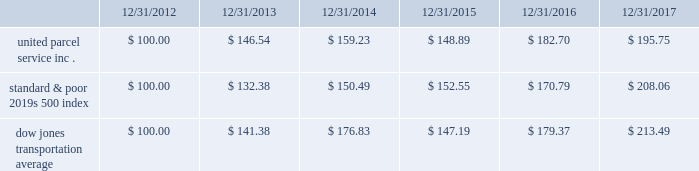Shareowner return performance graph the following performance graph and related information shall not be deemed 201csoliciting material 201d or to be 201cfiled 201d with the sec , nor shall such information be incorporated by reference into any future filing under the securities act of 1933 or securities exchange act of 1934 , each as amended , except to the extent that the company specifically incorporates such information by reference into such filing .
The following graph shows a five-year comparison of cumulative total shareowners 2019 returns for our class b common stock , the standard & poor 2019s 500 index and the dow jones transportation average .
The comparison of the total cumulative return on investment , which is the change in the quarterly stock price plus reinvested dividends for each of the quarterly periods , assumes that $ 100 was invested on december 31 , 2012 in the standard & poor 2019s 500 index , the dow jones transportation average and our class b common stock. .

What is the total cumulative percentage return on investment on class b common stock for the five years ended 122/31/2017? 
Computations: ((195.75 - 100.00) / 100.00)
Answer: 0.9575. 